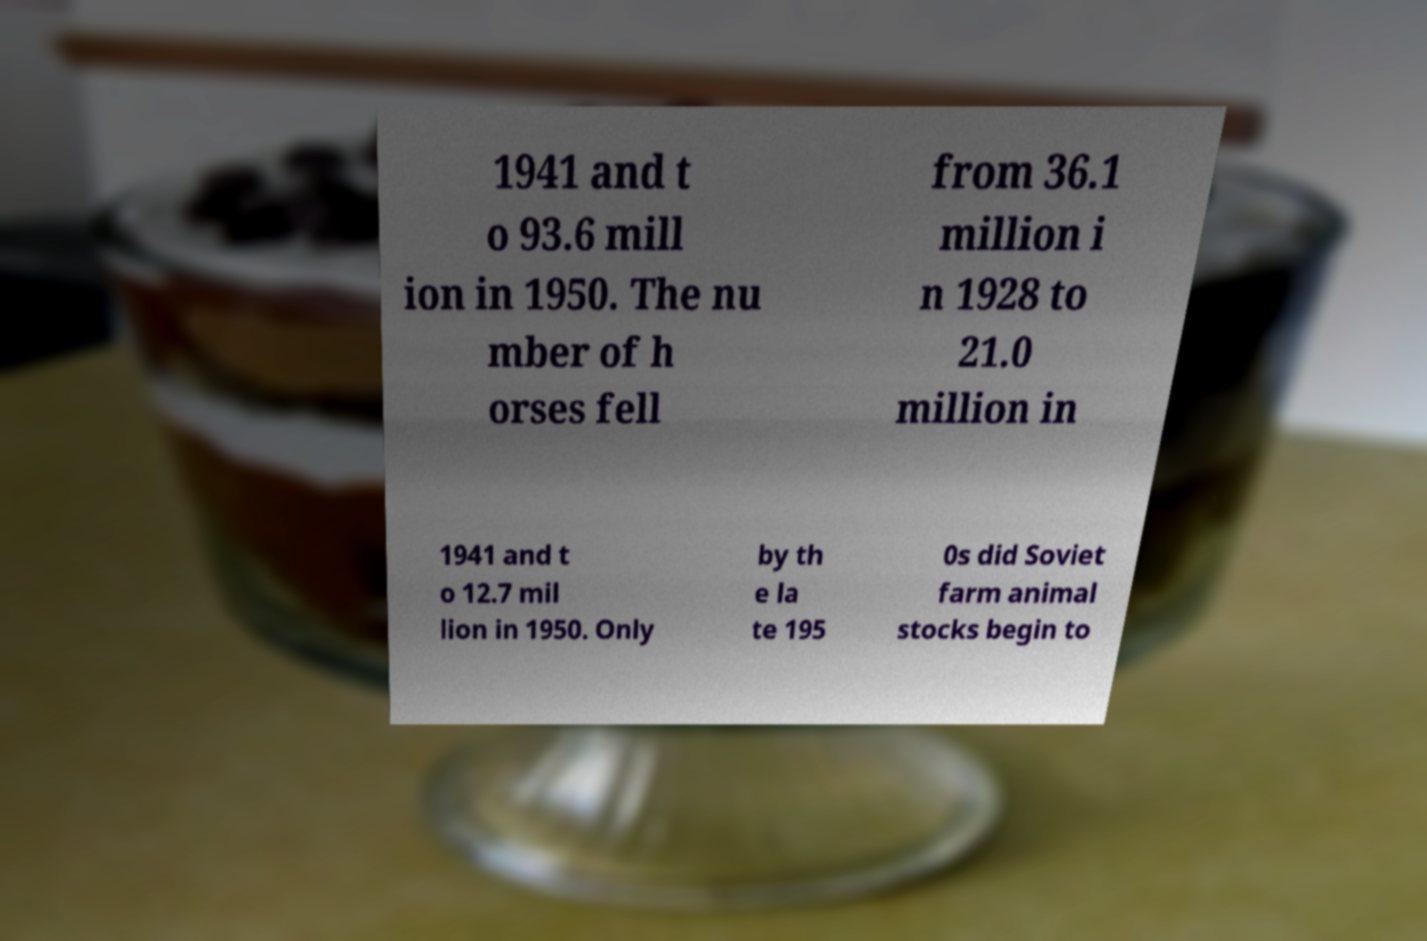Could you assist in decoding the text presented in this image and type it out clearly? 1941 and t o 93.6 mill ion in 1950. The nu mber of h orses fell from 36.1 million i n 1928 to 21.0 million in 1941 and t o 12.7 mil lion in 1950. Only by th e la te 195 0s did Soviet farm animal stocks begin to 